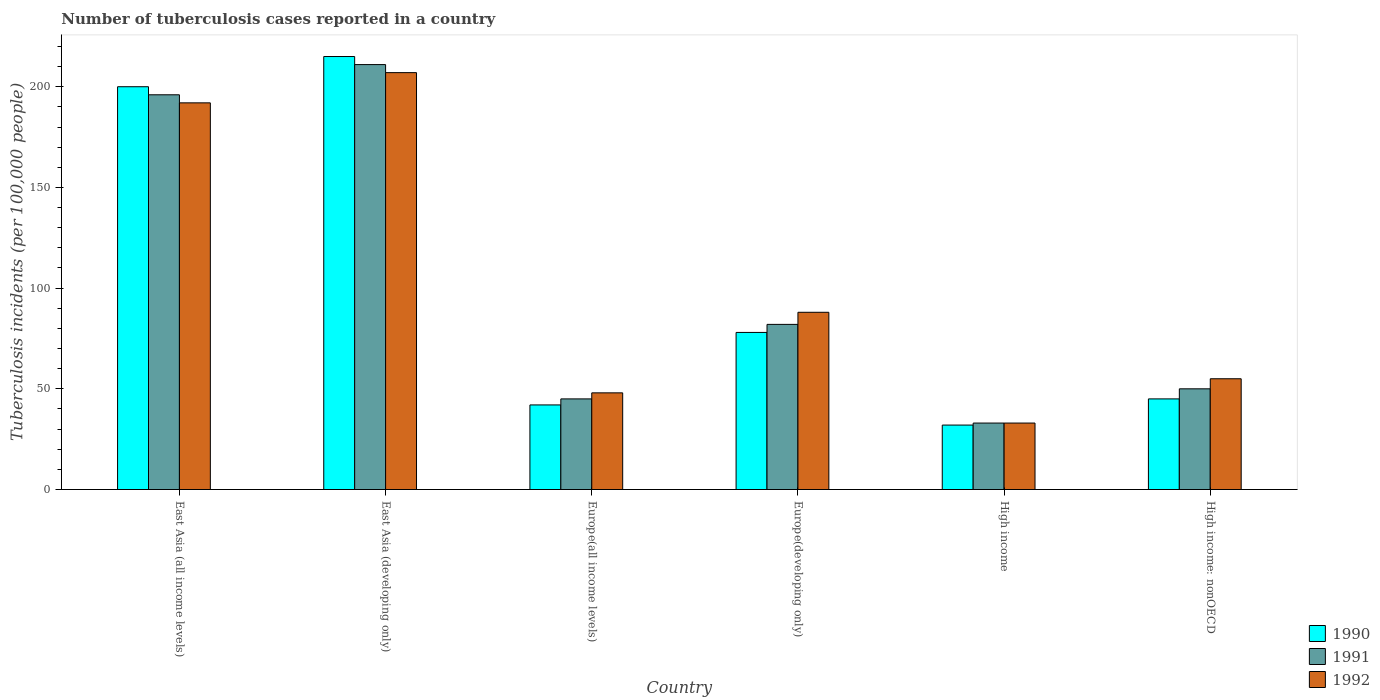How many groups of bars are there?
Offer a terse response. 6. Are the number of bars per tick equal to the number of legend labels?
Provide a short and direct response. Yes. How many bars are there on the 4th tick from the left?
Your response must be concise. 3. How many bars are there on the 6th tick from the right?
Your response must be concise. 3. What is the number of tuberculosis cases reported in in 1992 in Europe(all income levels)?
Ensure brevity in your answer.  48. Across all countries, what is the maximum number of tuberculosis cases reported in in 1990?
Give a very brief answer. 215. Across all countries, what is the minimum number of tuberculosis cases reported in in 1992?
Give a very brief answer. 33. In which country was the number of tuberculosis cases reported in in 1991 maximum?
Offer a very short reply. East Asia (developing only). What is the total number of tuberculosis cases reported in in 1992 in the graph?
Make the answer very short. 623. What is the difference between the number of tuberculosis cases reported in in 1990 in East Asia (developing only) and that in Europe(developing only)?
Give a very brief answer. 137. What is the average number of tuberculosis cases reported in in 1992 per country?
Provide a short and direct response. 103.83. What is the difference between the number of tuberculosis cases reported in of/in 1991 and number of tuberculosis cases reported in of/in 1990 in Europe(all income levels)?
Your answer should be very brief. 3. What is the ratio of the number of tuberculosis cases reported in in 1990 in East Asia (all income levels) to that in Europe(developing only)?
Keep it short and to the point. 2.56. Is the number of tuberculosis cases reported in in 1990 in East Asia (all income levels) less than that in Europe(all income levels)?
Ensure brevity in your answer.  No. What is the difference between the highest and the second highest number of tuberculosis cases reported in in 1992?
Provide a short and direct response. 104. What is the difference between the highest and the lowest number of tuberculosis cases reported in in 1990?
Make the answer very short. 183. What does the 1st bar from the right in Europe(all income levels) represents?
Your answer should be compact. 1992. How many bars are there?
Your answer should be very brief. 18. Does the graph contain any zero values?
Your response must be concise. No. Where does the legend appear in the graph?
Your answer should be very brief. Bottom right. What is the title of the graph?
Make the answer very short. Number of tuberculosis cases reported in a country. Does "1988" appear as one of the legend labels in the graph?
Your answer should be compact. No. What is the label or title of the X-axis?
Make the answer very short. Country. What is the label or title of the Y-axis?
Offer a terse response. Tuberculosis incidents (per 100,0 people). What is the Tuberculosis incidents (per 100,000 people) of 1990 in East Asia (all income levels)?
Your response must be concise. 200. What is the Tuberculosis incidents (per 100,000 people) of 1991 in East Asia (all income levels)?
Your response must be concise. 196. What is the Tuberculosis incidents (per 100,000 people) of 1992 in East Asia (all income levels)?
Provide a short and direct response. 192. What is the Tuberculosis incidents (per 100,000 people) of 1990 in East Asia (developing only)?
Give a very brief answer. 215. What is the Tuberculosis incidents (per 100,000 people) of 1991 in East Asia (developing only)?
Provide a succinct answer. 211. What is the Tuberculosis incidents (per 100,000 people) of 1992 in East Asia (developing only)?
Offer a terse response. 207. What is the Tuberculosis incidents (per 100,000 people) in 1992 in Europe(all income levels)?
Keep it short and to the point. 48. What is the Tuberculosis incidents (per 100,000 people) in 1990 in Europe(developing only)?
Offer a very short reply. 78. What is the Tuberculosis incidents (per 100,000 people) of 1991 in Europe(developing only)?
Your answer should be compact. 82. What is the Tuberculosis incidents (per 100,000 people) of 1990 in High income?
Provide a short and direct response. 32. What is the Tuberculosis incidents (per 100,000 people) in 1991 in High income?
Make the answer very short. 33. What is the Tuberculosis incidents (per 100,000 people) in 1990 in High income: nonOECD?
Keep it short and to the point. 45. What is the Tuberculosis incidents (per 100,000 people) in 1991 in High income: nonOECD?
Offer a very short reply. 50. Across all countries, what is the maximum Tuberculosis incidents (per 100,000 people) of 1990?
Offer a very short reply. 215. Across all countries, what is the maximum Tuberculosis incidents (per 100,000 people) of 1991?
Offer a terse response. 211. Across all countries, what is the maximum Tuberculosis incidents (per 100,000 people) of 1992?
Make the answer very short. 207. Across all countries, what is the minimum Tuberculosis incidents (per 100,000 people) in 1992?
Keep it short and to the point. 33. What is the total Tuberculosis incidents (per 100,000 people) of 1990 in the graph?
Make the answer very short. 612. What is the total Tuberculosis incidents (per 100,000 people) of 1991 in the graph?
Your answer should be very brief. 617. What is the total Tuberculosis incidents (per 100,000 people) in 1992 in the graph?
Your answer should be compact. 623. What is the difference between the Tuberculosis incidents (per 100,000 people) of 1991 in East Asia (all income levels) and that in East Asia (developing only)?
Make the answer very short. -15. What is the difference between the Tuberculosis incidents (per 100,000 people) of 1990 in East Asia (all income levels) and that in Europe(all income levels)?
Offer a very short reply. 158. What is the difference between the Tuberculosis incidents (per 100,000 people) in 1991 in East Asia (all income levels) and that in Europe(all income levels)?
Provide a short and direct response. 151. What is the difference between the Tuberculosis incidents (per 100,000 people) in 1992 in East Asia (all income levels) and that in Europe(all income levels)?
Give a very brief answer. 144. What is the difference between the Tuberculosis incidents (per 100,000 people) in 1990 in East Asia (all income levels) and that in Europe(developing only)?
Ensure brevity in your answer.  122. What is the difference between the Tuberculosis incidents (per 100,000 people) in 1991 in East Asia (all income levels) and that in Europe(developing only)?
Ensure brevity in your answer.  114. What is the difference between the Tuberculosis incidents (per 100,000 people) of 1992 in East Asia (all income levels) and that in Europe(developing only)?
Keep it short and to the point. 104. What is the difference between the Tuberculosis incidents (per 100,000 people) of 1990 in East Asia (all income levels) and that in High income?
Offer a very short reply. 168. What is the difference between the Tuberculosis incidents (per 100,000 people) in 1991 in East Asia (all income levels) and that in High income?
Make the answer very short. 163. What is the difference between the Tuberculosis incidents (per 100,000 people) in 1992 in East Asia (all income levels) and that in High income?
Ensure brevity in your answer.  159. What is the difference between the Tuberculosis incidents (per 100,000 people) of 1990 in East Asia (all income levels) and that in High income: nonOECD?
Offer a very short reply. 155. What is the difference between the Tuberculosis incidents (per 100,000 people) in 1991 in East Asia (all income levels) and that in High income: nonOECD?
Give a very brief answer. 146. What is the difference between the Tuberculosis incidents (per 100,000 people) of 1992 in East Asia (all income levels) and that in High income: nonOECD?
Ensure brevity in your answer.  137. What is the difference between the Tuberculosis incidents (per 100,000 people) in 1990 in East Asia (developing only) and that in Europe(all income levels)?
Provide a succinct answer. 173. What is the difference between the Tuberculosis incidents (per 100,000 people) of 1991 in East Asia (developing only) and that in Europe(all income levels)?
Your answer should be very brief. 166. What is the difference between the Tuberculosis incidents (per 100,000 people) of 1992 in East Asia (developing only) and that in Europe(all income levels)?
Ensure brevity in your answer.  159. What is the difference between the Tuberculosis incidents (per 100,000 people) of 1990 in East Asia (developing only) and that in Europe(developing only)?
Provide a succinct answer. 137. What is the difference between the Tuberculosis incidents (per 100,000 people) of 1991 in East Asia (developing only) and that in Europe(developing only)?
Keep it short and to the point. 129. What is the difference between the Tuberculosis incidents (per 100,000 people) of 1992 in East Asia (developing only) and that in Europe(developing only)?
Your answer should be compact. 119. What is the difference between the Tuberculosis incidents (per 100,000 people) in 1990 in East Asia (developing only) and that in High income?
Provide a succinct answer. 183. What is the difference between the Tuberculosis incidents (per 100,000 people) in 1991 in East Asia (developing only) and that in High income?
Ensure brevity in your answer.  178. What is the difference between the Tuberculosis incidents (per 100,000 people) of 1992 in East Asia (developing only) and that in High income?
Your answer should be compact. 174. What is the difference between the Tuberculosis incidents (per 100,000 people) of 1990 in East Asia (developing only) and that in High income: nonOECD?
Your answer should be compact. 170. What is the difference between the Tuberculosis incidents (per 100,000 people) of 1991 in East Asia (developing only) and that in High income: nonOECD?
Ensure brevity in your answer.  161. What is the difference between the Tuberculosis incidents (per 100,000 people) of 1992 in East Asia (developing only) and that in High income: nonOECD?
Keep it short and to the point. 152. What is the difference between the Tuberculosis incidents (per 100,000 people) of 1990 in Europe(all income levels) and that in Europe(developing only)?
Your answer should be compact. -36. What is the difference between the Tuberculosis incidents (per 100,000 people) in 1991 in Europe(all income levels) and that in Europe(developing only)?
Provide a short and direct response. -37. What is the difference between the Tuberculosis incidents (per 100,000 people) in 1990 in Europe(all income levels) and that in High income?
Offer a terse response. 10. What is the difference between the Tuberculosis incidents (per 100,000 people) of 1992 in Europe(developing only) and that in High income?
Provide a succinct answer. 55. What is the difference between the Tuberculosis incidents (per 100,000 people) in 1990 in Europe(developing only) and that in High income: nonOECD?
Ensure brevity in your answer.  33. What is the difference between the Tuberculosis incidents (per 100,000 people) of 1991 in High income and that in High income: nonOECD?
Offer a terse response. -17. What is the difference between the Tuberculosis incidents (per 100,000 people) in 1990 in East Asia (all income levels) and the Tuberculosis incidents (per 100,000 people) in 1991 in East Asia (developing only)?
Offer a terse response. -11. What is the difference between the Tuberculosis incidents (per 100,000 people) of 1990 in East Asia (all income levels) and the Tuberculosis incidents (per 100,000 people) of 1992 in East Asia (developing only)?
Your answer should be compact. -7. What is the difference between the Tuberculosis incidents (per 100,000 people) in 1991 in East Asia (all income levels) and the Tuberculosis incidents (per 100,000 people) in 1992 in East Asia (developing only)?
Ensure brevity in your answer.  -11. What is the difference between the Tuberculosis incidents (per 100,000 people) of 1990 in East Asia (all income levels) and the Tuberculosis incidents (per 100,000 people) of 1991 in Europe(all income levels)?
Your answer should be very brief. 155. What is the difference between the Tuberculosis incidents (per 100,000 people) in 1990 in East Asia (all income levels) and the Tuberculosis incidents (per 100,000 people) in 1992 in Europe(all income levels)?
Offer a very short reply. 152. What is the difference between the Tuberculosis incidents (per 100,000 people) in 1991 in East Asia (all income levels) and the Tuberculosis incidents (per 100,000 people) in 1992 in Europe(all income levels)?
Provide a short and direct response. 148. What is the difference between the Tuberculosis incidents (per 100,000 people) in 1990 in East Asia (all income levels) and the Tuberculosis incidents (per 100,000 people) in 1991 in Europe(developing only)?
Ensure brevity in your answer.  118. What is the difference between the Tuberculosis incidents (per 100,000 people) of 1990 in East Asia (all income levels) and the Tuberculosis incidents (per 100,000 people) of 1992 in Europe(developing only)?
Your answer should be compact. 112. What is the difference between the Tuberculosis incidents (per 100,000 people) in 1991 in East Asia (all income levels) and the Tuberculosis incidents (per 100,000 people) in 1992 in Europe(developing only)?
Offer a terse response. 108. What is the difference between the Tuberculosis incidents (per 100,000 people) of 1990 in East Asia (all income levels) and the Tuberculosis incidents (per 100,000 people) of 1991 in High income?
Your answer should be compact. 167. What is the difference between the Tuberculosis incidents (per 100,000 people) of 1990 in East Asia (all income levels) and the Tuberculosis incidents (per 100,000 people) of 1992 in High income?
Provide a short and direct response. 167. What is the difference between the Tuberculosis incidents (per 100,000 people) of 1991 in East Asia (all income levels) and the Tuberculosis incidents (per 100,000 people) of 1992 in High income?
Your answer should be compact. 163. What is the difference between the Tuberculosis incidents (per 100,000 people) of 1990 in East Asia (all income levels) and the Tuberculosis incidents (per 100,000 people) of 1991 in High income: nonOECD?
Your response must be concise. 150. What is the difference between the Tuberculosis incidents (per 100,000 people) of 1990 in East Asia (all income levels) and the Tuberculosis incidents (per 100,000 people) of 1992 in High income: nonOECD?
Offer a very short reply. 145. What is the difference between the Tuberculosis incidents (per 100,000 people) in 1991 in East Asia (all income levels) and the Tuberculosis incidents (per 100,000 people) in 1992 in High income: nonOECD?
Provide a succinct answer. 141. What is the difference between the Tuberculosis incidents (per 100,000 people) in 1990 in East Asia (developing only) and the Tuberculosis incidents (per 100,000 people) in 1991 in Europe(all income levels)?
Offer a very short reply. 170. What is the difference between the Tuberculosis incidents (per 100,000 people) in 1990 in East Asia (developing only) and the Tuberculosis incidents (per 100,000 people) in 1992 in Europe(all income levels)?
Provide a short and direct response. 167. What is the difference between the Tuberculosis incidents (per 100,000 people) of 1991 in East Asia (developing only) and the Tuberculosis incidents (per 100,000 people) of 1992 in Europe(all income levels)?
Give a very brief answer. 163. What is the difference between the Tuberculosis incidents (per 100,000 people) of 1990 in East Asia (developing only) and the Tuberculosis incidents (per 100,000 people) of 1991 in Europe(developing only)?
Offer a terse response. 133. What is the difference between the Tuberculosis incidents (per 100,000 people) of 1990 in East Asia (developing only) and the Tuberculosis incidents (per 100,000 people) of 1992 in Europe(developing only)?
Provide a short and direct response. 127. What is the difference between the Tuberculosis incidents (per 100,000 people) of 1991 in East Asia (developing only) and the Tuberculosis incidents (per 100,000 people) of 1992 in Europe(developing only)?
Provide a short and direct response. 123. What is the difference between the Tuberculosis incidents (per 100,000 people) of 1990 in East Asia (developing only) and the Tuberculosis incidents (per 100,000 people) of 1991 in High income?
Ensure brevity in your answer.  182. What is the difference between the Tuberculosis incidents (per 100,000 people) in 1990 in East Asia (developing only) and the Tuberculosis incidents (per 100,000 people) in 1992 in High income?
Offer a very short reply. 182. What is the difference between the Tuberculosis incidents (per 100,000 people) of 1991 in East Asia (developing only) and the Tuberculosis incidents (per 100,000 people) of 1992 in High income?
Keep it short and to the point. 178. What is the difference between the Tuberculosis incidents (per 100,000 people) of 1990 in East Asia (developing only) and the Tuberculosis incidents (per 100,000 people) of 1991 in High income: nonOECD?
Your response must be concise. 165. What is the difference between the Tuberculosis incidents (per 100,000 people) in 1990 in East Asia (developing only) and the Tuberculosis incidents (per 100,000 people) in 1992 in High income: nonOECD?
Provide a short and direct response. 160. What is the difference between the Tuberculosis incidents (per 100,000 people) in 1991 in East Asia (developing only) and the Tuberculosis incidents (per 100,000 people) in 1992 in High income: nonOECD?
Provide a short and direct response. 156. What is the difference between the Tuberculosis incidents (per 100,000 people) of 1990 in Europe(all income levels) and the Tuberculosis incidents (per 100,000 people) of 1992 in Europe(developing only)?
Make the answer very short. -46. What is the difference between the Tuberculosis incidents (per 100,000 people) of 1991 in Europe(all income levels) and the Tuberculosis incidents (per 100,000 people) of 1992 in Europe(developing only)?
Offer a very short reply. -43. What is the difference between the Tuberculosis incidents (per 100,000 people) of 1990 in Europe(all income levels) and the Tuberculosis incidents (per 100,000 people) of 1992 in High income?
Offer a terse response. 9. What is the difference between the Tuberculosis incidents (per 100,000 people) of 1991 in Europe(all income levels) and the Tuberculosis incidents (per 100,000 people) of 1992 in High income?
Your response must be concise. 12. What is the difference between the Tuberculosis incidents (per 100,000 people) of 1990 in Europe(all income levels) and the Tuberculosis incidents (per 100,000 people) of 1992 in High income: nonOECD?
Ensure brevity in your answer.  -13. What is the difference between the Tuberculosis incidents (per 100,000 people) of 1991 in Europe(all income levels) and the Tuberculosis incidents (per 100,000 people) of 1992 in High income: nonOECD?
Offer a terse response. -10. What is the difference between the Tuberculosis incidents (per 100,000 people) of 1990 in Europe(developing only) and the Tuberculosis incidents (per 100,000 people) of 1992 in High income?
Keep it short and to the point. 45. What is the difference between the Tuberculosis incidents (per 100,000 people) in 1990 in Europe(developing only) and the Tuberculosis incidents (per 100,000 people) in 1991 in High income: nonOECD?
Your response must be concise. 28. What is the difference between the Tuberculosis incidents (per 100,000 people) of 1990 in High income and the Tuberculosis incidents (per 100,000 people) of 1992 in High income: nonOECD?
Provide a short and direct response. -23. What is the average Tuberculosis incidents (per 100,000 people) in 1990 per country?
Give a very brief answer. 102. What is the average Tuberculosis incidents (per 100,000 people) of 1991 per country?
Provide a short and direct response. 102.83. What is the average Tuberculosis incidents (per 100,000 people) in 1992 per country?
Give a very brief answer. 103.83. What is the difference between the Tuberculosis incidents (per 100,000 people) in 1990 and Tuberculosis incidents (per 100,000 people) in 1991 in East Asia (all income levels)?
Provide a succinct answer. 4. What is the difference between the Tuberculosis incidents (per 100,000 people) in 1990 and Tuberculosis incidents (per 100,000 people) in 1992 in East Asia (all income levels)?
Keep it short and to the point. 8. What is the difference between the Tuberculosis incidents (per 100,000 people) of 1990 and Tuberculosis incidents (per 100,000 people) of 1991 in East Asia (developing only)?
Your answer should be very brief. 4. What is the difference between the Tuberculosis incidents (per 100,000 people) in 1990 and Tuberculosis incidents (per 100,000 people) in 1992 in East Asia (developing only)?
Keep it short and to the point. 8. What is the difference between the Tuberculosis incidents (per 100,000 people) of 1991 and Tuberculosis incidents (per 100,000 people) of 1992 in East Asia (developing only)?
Make the answer very short. 4. What is the difference between the Tuberculosis incidents (per 100,000 people) in 1990 and Tuberculosis incidents (per 100,000 people) in 1991 in Europe(all income levels)?
Your response must be concise. -3. What is the difference between the Tuberculosis incidents (per 100,000 people) in 1991 and Tuberculosis incidents (per 100,000 people) in 1992 in Europe(all income levels)?
Your response must be concise. -3. What is the difference between the Tuberculosis incidents (per 100,000 people) in 1990 and Tuberculosis incidents (per 100,000 people) in 1991 in Europe(developing only)?
Ensure brevity in your answer.  -4. What is the difference between the Tuberculosis incidents (per 100,000 people) in 1991 and Tuberculosis incidents (per 100,000 people) in 1992 in High income: nonOECD?
Provide a succinct answer. -5. What is the ratio of the Tuberculosis incidents (per 100,000 people) of 1990 in East Asia (all income levels) to that in East Asia (developing only)?
Provide a short and direct response. 0.93. What is the ratio of the Tuberculosis incidents (per 100,000 people) of 1991 in East Asia (all income levels) to that in East Asia (developing only)?
Provide a succinct answer. 0.93. What is the ratio of the Tuberculosis incidents (per 100,000 people) of 1992 in East Asia (all income levels) to that in East Asia (developing only)?
Your response must be concise. 0.93. What is the ratio of the Tuberculosis incidents (per 100,000 people) of 1990 in East Asia (all income levels) to that in Europe(all income levels)?
Your response must be concise. 4.76. What is the ratio of the Tuberculosis incidents (per 100,000 people) in 1991 in East Asia (all income levels) to that in Europe(all income levels)?
Ensure brevity in your answer.  4.36. What is the ratio of the Tuberculosis incidents (per 100,000 people) in 1990 in East Asia (all income levels) to that in Europe(developing only)?
Give a very brief answer. 2.56. What is the ratio of the Tuberculosis incidents (per 100,000 people) of 1991 in East Asia (all income levels) to that in Europe(developing only)?
Your response must be concise. 2.39. What is the ratio of the Tuberculosis incidents (per 100,000 people) of 1992 in East Asia (all income levels) to that in Europe(developing only)?
Give a very brief answer. 2.18. What is the ratio of the Tuberculosis incidents (per 100,000 people) of 1990 in East Asia (all income levels) to that in High income?
Your response must be concise. 6.25. What is the ratio of the Tuberculosis incidents (per 100,000 people) in 1991 in East Asia (all income levels) to that in High income?
Your answer should be compact. 5.94. What is the ratio of the Tuberculosis incidents (per 100,000 people) in 1992 in East Asia (all income levels) to that in High income?
Offer a terse response. 5.82. What is the ratio of the Tuberculosis incidents (per 100,000 people) in 1990 in East Asia (all income levels) to that in High income: nonOECD?
Your answer should be compact. 4.44. What is the ratio of the Tuberculosis incidents (per 100,000 people) of 1991 in East Asia (all income levels) to that in High income: nonOECD?
Give a very brief answer. 3.92. What is the ratio of the Tuberculosis incidents (per 100,000 people) of 1992 in East Asia (all income levels) to that in High income: nonOECD?
Ensure brevity in your answer.  3.49. What is the ratio of the Tuberculosis incidents (per 100,000 people) of 1990 in East Asia (developing only) to that in Europe(all income levels)?
Your response must be concise. 5.12. What is the ratio of the Tuberculosis incidents (per 100,000 people) in 1991 in East Asia (developing only) to that in Europe(all income levels)?
Keep it short and to the point. 4.69. What is the ratio of the Tuberculosis incidents (per 100,000 people) in 1992 in East Asia (developing only) to that in Europe(all income levels)?
Offer a terse response. 4.31. What is the ratio of the Tuberculosis incidents (per 100,000 people) in 1990 in East Asia (developing only) to that in Europe(developing only)?
Your answer should be compact. 2.76. What is the ratio of the Tuberculosis incidents (per 100,000 people) of 1991 in East Asia (developing only) to that in Europe(developing only)?
Your answer should be compact. 2.57. What is the ratio of the Tuberculosis incidents (per 100,000 people) in 1992 in East Asia (developing only) to that in Europe(developing only)?
Keep it short and to the point. 2.35. What is the ratio of the Tuberculosis incidents (per 100,000 people) of 1990 in East Asia (developing only) to that in High income?
Your response must be concise. 6.72. What is the ratio of the Tuberculosis incidents (per 100,000 people) of 1991 in East Asia (developing only) to that in High income?
Provide a succinct answer. 6.39. What is the ratio of the Tuberculosis incidents (per 100,000 people) in 1992 in East Asia (developing only) to that in High income?
Your answer should be very brief. 6.27. What is the ratio of the Tuberculosis incidents (per 100,000 people) in 1990 in East Asia (developing only) to that in High income: nonOECD?
Your answer should be compact. 4.78. What is the ratio of the Tuberculosis incidents (per 100,000 people) of 1991 in East Asia (developing only) to that in High income: nonOECD?
Your response must be concise. 4.22. What is the ratio of the Tuberculosis incidents (per 100,000 people) in 1992 in East Asia (developing only) to that in High income: nonOECD?
Offer a very short reply. 3.76. What is the ratio of the Tuberculosis incidents (per 100,000 people) of 1990 in Europe(all income levels) to that in Europe(developing only)?
Your response must be concise. 0.54. What is the ratio of the Tuberculosis incidents (per 100,000 people) of 1991 in Europe(all income levels) to that in Europe(developing only)?
Your response must be concise. 0.55. What is the ratio of the Tuberculosis incidents (per 100,000 people) of 1992 in Europe(all income levels) to that in Europe(developing only)?
Provide a short and direct response. 0.55. What is the ratio of the Tuberculosis incidents (per 100,000 people) of 1990 in Europe(all income levels) to that in High income?
Offer a very short reply. 1.31. What is the ratio of the Tuberculosis incidents (per 100,000 people) of 1991 in Europe(all income levels) to that in High income?
Your answer should be compact. 1.36. What is the ratio of the Tuberculosis incidents (per 100,000 people) of 1992 in Europe(all income levels) to that in High income?
Make the answer very short. 1.45. What is the ratio of the Tuberculosis incidents (per 100,000 people) in 1991 in Europe(all income levels) to that in High income: nonOECD?
Offer a very short reply. 0.9. What is the ratio of the Tuberculosis incidents (per 100,000 people) of 1992 in Europe(all income levels) to that in High income: nonOECD?
Your answer should be compact. 0.87. What is the ratio of the Tuberculosis incidents (per 100,000 people) of 1990 in Europe(developing only) to that in High income?
Your response must be concise. 2.44. What is the ratio of the Tuberculosis incidents (per 100,000 people) in 1991 in Europe(developing only) to that in High income?
Offer a terse response. 2.48. What is the ratio of the Tuberculosis incidents (per 100,000 people) of 1992 in Europe(developing only) to that in High income?
Give a very brief answer. 2.67. What is the ratio of the Tuberculosis incidents (per 100,000 people) in 1990 in Europe(developing only) to that in High income: nonOECD?
Your response must be concise. 1.73. What is the ratio of the Tuberculosis incidents (per 100,000 people) in 1991 in Europe(developing only) to that in High income: nonOECD?
Your answer should be compact. 1.64. What is the ratio of the Tuberculosis incidents (per 100,000 people) of 1992 in Europe(developing only) to that in High income: nonOECD?
Your answer should be very brief. 1.6. What is the ratio of the Tuberculosis incidents (per 100,000 people) of 1990 in High income to that in High income: nonOECD?
Your answer should be compact. 0.71. What is the ratio of the Tuberculosis incidents (per 100,000 people) in 1991 in High income to that in High income: nonOECD?
Your answer should be compact. 0.66. What is the ratio of the Tuberculosis incidents (per 100,000 people) of 1992 in High income to that in High income: nonOECD?
Keep it short and to the point. 0.6. What is the difference between the highest and the second highest Tuberculosis incidents (per 100,000 people) of 1990?
Keep it short and to the point. 15. What is the difference between the highest and the second highest Tuberculosis incidents (per 100,000 people) in 1992?
Ensure brevity in your answer.  15. What is the difference between the highest and the lowest Tuberculosis incidents (per 100,000 people) of 1990?
Keep it short and to the point. 183. What is the difference between the highest and the lowest Tuberculosis incidents (per 100,000 people) in 1991?
Your answer should be compact. 178. What is the difference between the highest and the lowest Tuberculosis incidents (per 100,000 people) of 1992?
Ensure brevity in your answer.  174. 